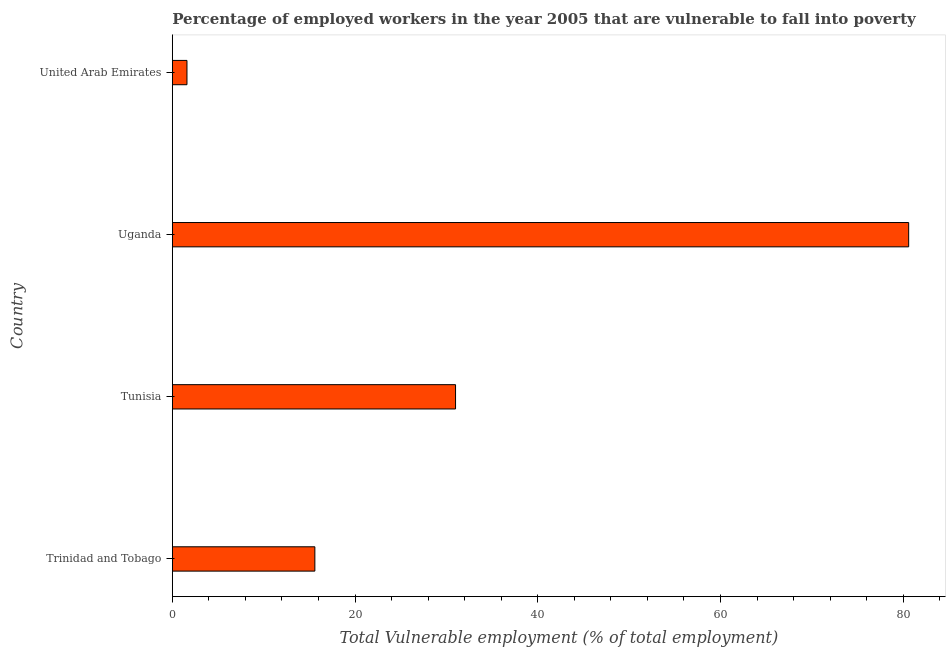Does the graph contain any zero values?
Make the answer very short. No. What is the title of the graph?
Keep it short and to the point. Percentage of employed workers in the year 2005 that are vulnerable to fall into poverty. What is the label or title of the X-axis?
Offer a very short reply. Total Vulnerable employment (% of total employment). What is the label or title of the Y-axis?
Ensure brevity in your answer.  Country. What is the total vulnerable employment in Uganda?
Offer a terse response. 80.6. Across all countries, what is the maximum total vulnerable employment?
Your answer should be compact. 80.6. Across all countries, what is the minimum total vulnerable employment?
Make the answer very short. 1.6. In which country was the total vulnerable employment maximum?
Ensure brevity in your answer.  Uganda. In which country was the total vulnerable employment minimum?
Your answer should be very brief. United Arab Emirates. What is the sum of the total vulnerable employment?
Provide a short and direct response. 128.8. What is the difference between the total vulnerable employment in Trinidad and Tobago and United Arab Emirates?
Provide a short and direct response. 14. What is the average total vulnerable employment per country?
Your answer should be compact. 32.2. What is the median total vulnerable employment?
Your answer should be very brief. 23.3. What is the ratio of the total vulnerable employment in Tunisia to that in Uganda?
Make the answer very short. 0.39. What is the difference between the highest and the second highest total vulnerable employment?
Offer a very short reply. 49.6. What is the difference between the highest and the lowest total vulnerable employment?
Provide a short and direct response. 79. In how many countries, is the total vulnerable employment greater than the average total vulnerable employment taken over all countries?
Your answer should be compact. 1. Are all the bars in the graph horizontal?
Offer a very short reply. Yes. What is the Total Vulnerable employment (% of total employment) in Trinidad and Tobago?
Give a very brief answer. 15.6. What is the Total Vulnerable employment (% of total employment) in Tunisia?
Ensure brevity in your answer.  31. What is the Total Vulnerable employment (% of total employment) in Uganda?
Keep it short and to the point. 80.6. What is the Total Vulnerable employment (% of total employment) in United Arab Emirates?
Offer a terse response. 1.6. What is the difference between the Total Vulnerable employment (% of total employment) in Trinidad and Tobago and Tunisia?
Offer a very short reply. -15.4. What is the difference between the Total Vulnerable employment (% of total employment) in Trinidad and Tobago and Uganda?
Provide a succinct answer. -65. What is the difference between the Total Vulnerable employment (% of total employment) in Trinidad and Tobago and United Arab Emirates?
Give a very brief answer. 14. What is the difference between the Total Vulnerable employment (% of total employment) in Tunisia and Uganda?
Your response must be concise. -49.6. What is the difference between the Total Vulnerable employment (% of total employment) in Tunisia and United Arab Emirates?
Make the answer very short. 29.4. What is the difference between the Total Vulnerable employment (% of total employment) in Uganda and United Arab Emirates?
Ensure brevity in your answer.  79. What is the ratio of the Total Vulnerable employment (% of total employment) in Trinidad and Tobago to that in Tunisia?
Keep it short and to the point. 0.5. What is the ratio of the Total Vulnerable employment (% of total employment) in Trinidad and Tobago to that in Uganda?
Provide a succinct answer. 0.19. What is the ratio of the Total Vulnerable employment (% of total employment) in Trinidad and Tobago to that in United Arab Emirates?
Give a very brief answer. 9.75. What is the ratio of the Total Vulnerable employment (% of total employment) in Tunisia to that in Uganda?
Your answer should be very brief. 0.39. What is the ratio of the Total Vulnerable employment (% of total employment) in Tunisia to that in United Arab Emirates?
Keep it short and to the point. 19.38. What is the ratio of the Total Vulnerable employment (% of total employment) in Uganda to that in United Arab Emirates?
Your answer should be very brief. 50.38. 